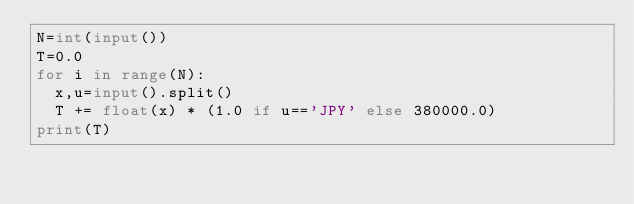<code> <loc_0><loc_0><loc_500><loc_500><_Python_>N=int(input())
T=0.0
for i in range(N):
  x,u=input().split()
  T += float(x) * (1.0 if u=='JPY' else 380000.0)
print(T)
</code> 